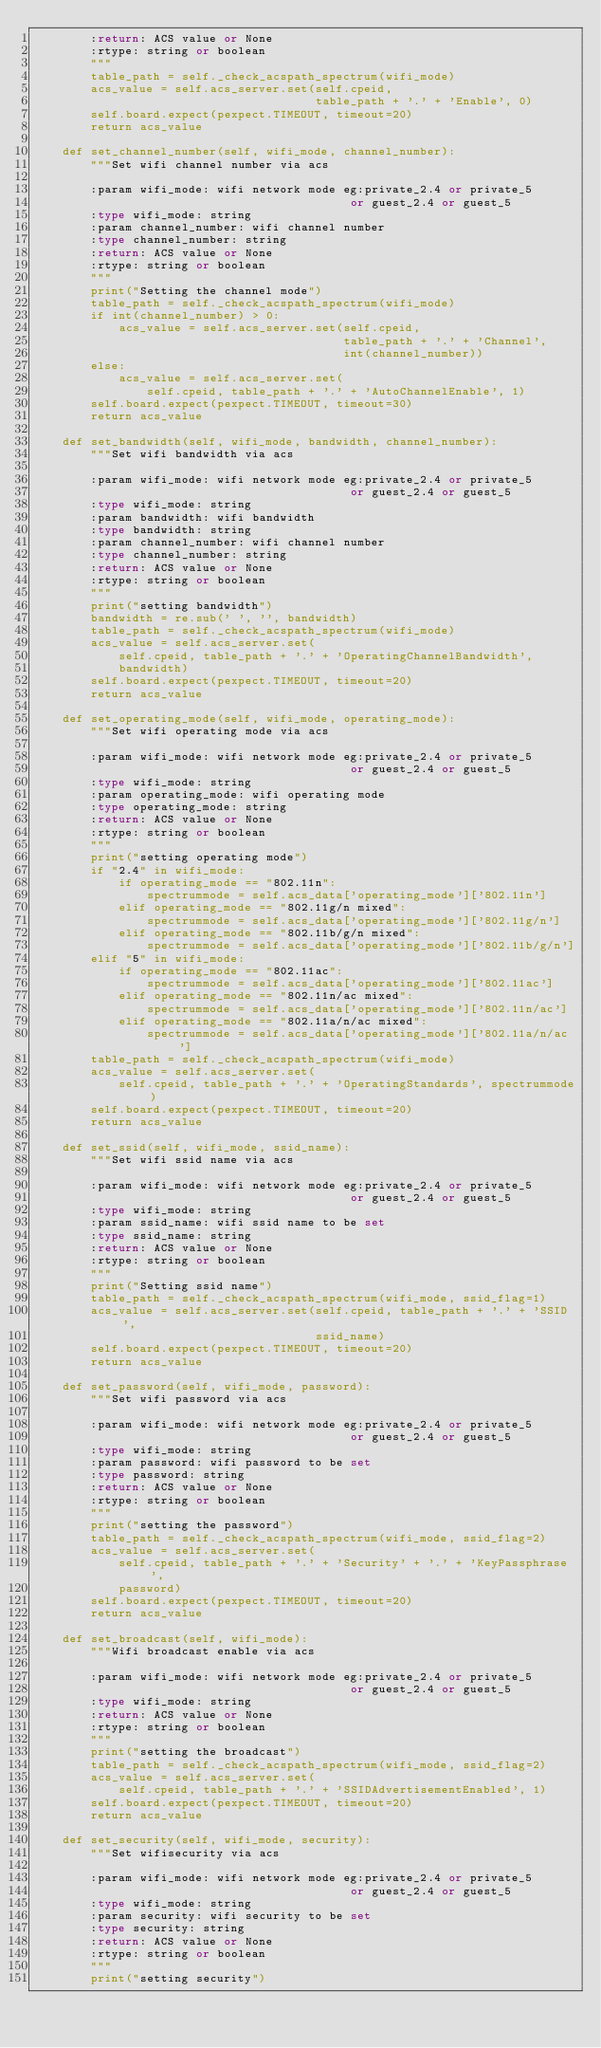Convert code to text. <code><loc_0><loc_0><loc_500><loc_500><_Python_>        :return: ACS value or None
        :rtype: string or boolean
        """
        table_path = self._check_acspath_spectrum(wifi_mode)
        acs_value = self.acs_server.set(self.cpeid,
                                        table_path + '.' + 'Enable', 0)
        self.board.expect(pexpect.TIMEOUT, timeout=20)
        return acs_value

    def set_channel_number(self, wifi_mode, channel_number):
        """Set wifi channel number via acs

        :param wifi_mode: wifi network mode eg:private_2.4 or private_5
                                             or guest_2.4 or guest_5
        :type wifi_mode: string
        :param channel_number: wifi channel number
        :type channel_number: string
        :return: ACS value or None
        :rtype: string or boolean
        """
        print("Setting the channel mode")
        table_path = self._check_acspath_spectrum(wifi_mode)
        if int(channel_number) > 0:
            acs_value = self.acs_server.set(self.cpeid,
                                            table_path + '.' + 'Channel',
                                            int(channel_number))
        else:
            acs_value = self.acs_server.set(
                self.cpeid, table_path + '.' + 'AutoChannelEnable', 1)
        self.board.expect(pexpect.TIMEOUT, timeout=30)
        return acs_value

    def set_bandwidth(self, wifi_mode, bandwidth, channel_number):
        """Set wifi bandwidth via acs

        :param wifi_mode: wifi network mode eg:private_2.4 or private_5
                                             or guest_2.4 or guest_5
        :type wifi_mode: string
        :param bandwidth: wifi bandwidth
        :type bandwidth: string
        :param channel_number: wifi channel number
        :type channel_number: string
        :return: ACS value or None
        :rtype: string or boolean
        """
        print("setting bandwidth")
        bandwidth = re.sub(' ', '', bandwidth)
        table_path = self._check_acspath_spectrum(wifi_mode)
        acs_value = self.acs_server.set(
            self.cpeid, table_path + '.' + 'OperatingChannelBandwidth',
            bandwidth)
        self.board.expect(pexpect.TIMEOUT, timeout=20)
        return acs_value

    def set_operating_mode(self, wifi_mode, operating_mode):
        """Set wifi operating mode via acs

        :param wifi_mode: wifi network mode eg:private_2.4 or private_5
                                             or guest_2.4 or guest_5
        :type wifi_mode: string
        :param operating_mode: wifi operating mode
        :type operating_mode: string
        :return: ACS value or None
        :rtype: string or boolean
        """
        print("setting operating mode")
        if "2.4" in wifi_mode:
            if operating_mode == "802.11n":
                spectrummode = self.acs_data['operating_mode']['802.11n']
            elif operating_mode == "802.11g/n mixed":
                spectrummode = self.acs_data['operating_mode']['802.11g/n']
            elif operating_mode == "802.11b/g/n mixed":
                spectrummode = self.acs_data['operating_mode']['802.11b/g/n']
        elif "5" in wifi_mode:
            if operating_mode == "802.11ac":
                spectrummode = self.acs_data['operating_mode']['802.11ac']
            elif operating_mode == "802.11n/ac mixed":
                spectrummode = self.acs_data['operating_mode']['802.11n/ac']
            elif operating_mode == "802.11a/n/ac mixed":
                spectrummode = self.acs_data['operating_mode']['802.11a/n/ac']
        table_path = self._check_acspath_spectrum(wifi_mode)
        acs_value = self.acs_server.set(
            self.cpeid, table_path + '.' + 'OperatingStandards', spectrummode)
        self.board.expect(pexpect.TIMEOUT, timeout=20)
        return acs_value

    def set_ssid(self, wifi_mode, ssid_name):
        """Set wifi ssid name via acs

        :param wifi_mode: wifi network mode eg:private_2.4 or private_5
                                             or guest_2.4 or guest_5
        :type wifi_mode: string
        :param ssid_name: wifi ssid name to be set
        :type ssid_name: string
        :return: ACS value or None
        :rtype: string or boolean
        """
        print("Setting ssid name")
        table_path = self._check_acspath_spectrum(wifi_mode, ssid_flag=1)
        acs_value = self.acs_server.set(self.cpeid, table_path + '.' + 'SSID',
                                        ssid_name)
        self.board.expect(pexpect.TIMEOUT, timeout=20)
        return acs_value

    def set_password(self, wifi_mode, password):
        """Set wifi password via acs

        :param wifi_mode: wifi network mode eg:private_2.4 or private_5
                                             or guest_2.4 or guest_5
        :type wifi_mode: string
        :param password: wifi password to be set
        :type password: string
        :return: ACS value or None
        :rtype: string or boolean
        """
        print("setting the password")
        table_path = self._check_acspath_spectrum(wifi_mode, ssid_flag=2)
        acs_value = self.acs_server.set(
            self.cpeid, table_path + '.' + 'Security' + '.' + 'KeyPassphrase',
            password)
        self.board.expect(pexpect.TIMEOUT, timeout=20)
        return acs_value

    def set_broadcast(self, wifi_mode):
        """Wifi broadcast enable via acs

        :param wifi_mode: wifi network mode eg:private_2.4 or private_5
                                             or guest_2.4 or guest_5
        :type wifi_mode: string
        :return: ACS value or None
        :rtype: string or boolean
        """
        print("setting the broadcast")
        table_path = self._check_acspath_spectrum(wifi_mode, ssid_flag=2)
        acs_value = self.acs_server.set(
            self.cpeid, table_path + '.' + 'SSIDAdvertisementEnabled', 1)
        self.board.expect(pexpect.TIMEOUT, timeout=20)
        return acs_value

    def set_security(self, wifi_mode, security):
        """Set wifisecurity via acs

        :param wifi_mode: wifi network mode eg:private_2.4 or private_5
                                             or guest_2.4 or guest_5
        :type wifi_mode: string
        :param security: wifi security to be set
        :type security: string
        :return: ACS value or None
        :rtype: string or boolean
        """
        print("setting security")</code> 